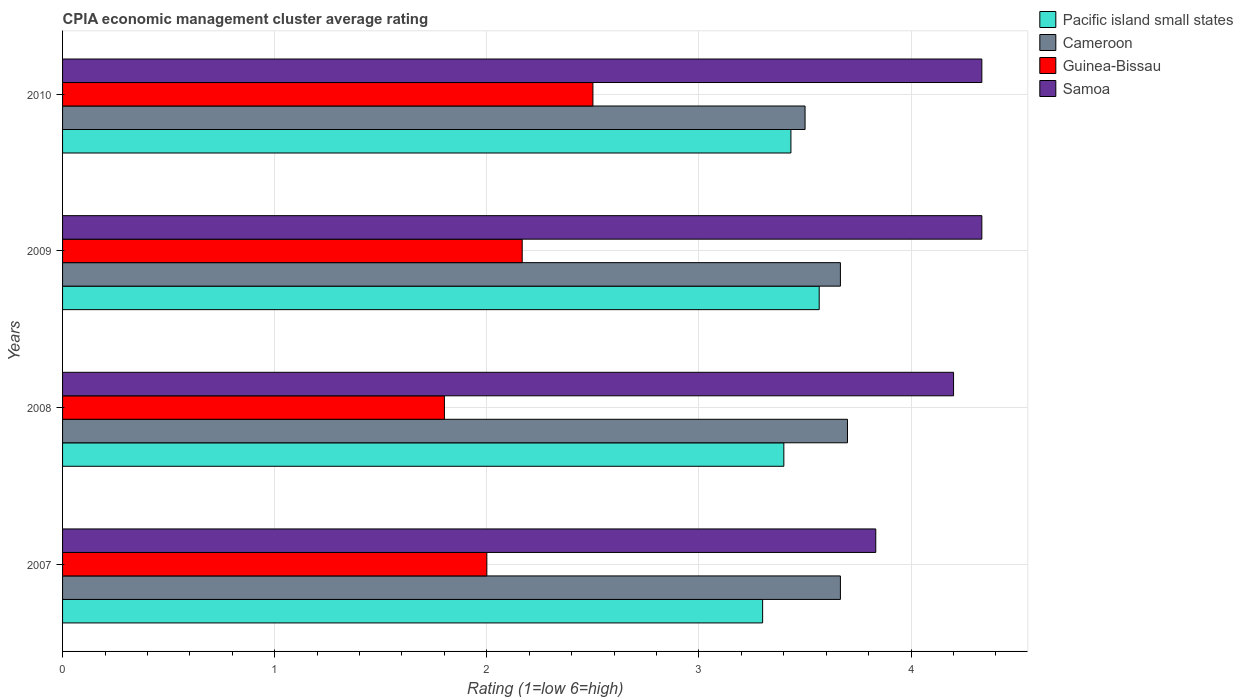How many different coloured bars are there?
Make the answer very short. 4. How many groups of bars are there?
Your answer should be very brief. 4. Are the number of bars per tick equal to the number of legend labels?
Make the answer very short. Yes. How many bars are there on the 1st tick from the top?
Your answer should be very brief. 4. What is the label of the 3rd group of bars from the top?
Your answer should be compact. 2008. In how many cases, is the number of bars for a given year not equal to the number of legend labels?
Your answer should be compact. 0. What is the CPIA rating in Pacific island small states in 2010?
Provide a short and direct response. 3.43. Across all years, what is the minimum CPIA rating in Cameroon?
Make the answer very short. 3.5. In which year was the CPIA rating in Pacific island small states maximum?
Ensure brevity in your answer.  2009. In which year was the CPIA rating in Cameroon minimum?
Provide a succinct answer. 2010. What is the total CPIA rating in Guinea-Bissau in the graph?
Your answer should be very brief. 8.47. What is the difference between the CPIA rating in Cameroon in 2007 and that in 2010?
Offer a very short reply. 0.17. What is the difference between the CPIA rating in Samoa in 2008 and the CPIA rating in Cameroon in 2007?
Offer a very short reply. 0.53. What is the average CPIA rating in Pacific island small states per year?
Provide a succinct answer. 3.42. In the year 2007, what is the difference between the CPIA rating in Samoa and CPIA rating in Pacific island small states?
Give a very brief answer. 0.53. What is the ratio of the CPIA rating in Guinea-Bissau in 2008 to that in 2009?
Your answer should be compact. 0.83. What is the difference between the highest and the second highest CPIA rating in Guinea-Bissau?
Offer a terse response. 0.33. What is the difference between the highest and the lowest CPIA rating in Cameroon?
Your answer should be compact. 0.2. In how many years, is the CPIA rating in Cameroon greater than the average CPIA rating in Cameroon taken over all years?
Offer a terse response. 3. Is it the case that in every year, the sum of the CPIA rating in Cameroon and CPIA rating in Pacific island small states is greater than the sum of CPIA rating in Guinea-Bissau and CPIA rating in Samoa?
Your answer should be very brief. Yes. What does the 4th bar from the top in 2008 represents?
Provide a succinct answer. Pacific island small states. What does the 3rd bar from the bottom in 2009 represents?
Your answer should be very brief. Guinea-Bissau. Are all the bars in the graph horizontal?
Offer a very short reply. Yes. Are the values on the major ticks of X-axis written in scientific E-notation?
Offer a very short reply. No. Does the graph contain grids?
Your answer should be compact. Yes. What is the title of the graph?
Keep it short and to the point. CPIA economic management cluster average rating. What is the Rating (1=low 6=high) in Pacific island small states in 2007?
Offer a terse response. 3.3. What is the Rating (1=low 6=high) of Cameroon in 2007?
Give a very brief answer. 3.67. What is the Rating (1=low 6=high) of Guinea-Bissau in 2007?
Ensure brevity in your answer.  2. What is the Rating (1=low 6=high) in Samoa in 2007?
Your answer should be very brief. 3.83. What is the Rating (1=low 6=high) in Guinea-Bissau in 2008?
Offer a very short reply. 1.8. What is the Rating (1=low 6=high) of Pacific island small states in 2009?
Keep it short and to the point. 3.57. What is the Rating (1=low 6=high) in Cameroon in 2009?
Offer a terse response. 3.67. What is the Rating (1=low 6=high) of Guinea-Bissau in 2009?
Your answer should be compact. 2.17. What is the Rating (1=low 6=high) of Samoa in 2009?
Make the answer very short. 4.33. What is the Rating (1=low 6=high) in Pacific island small states in 2010?
Your answer should be very brief. 3.43. What is the Rating (1=low 6=high) of Cameroon in 2010?
Your response must be concise. 3.5. What is the Rating (1=low 6=high) in Guinea-Bissau in 2010?
Make the answer very short. 2.5. What is the Rating (1=low 6=high) of Samoa in 2010?
Offer a very short reply. 4.33. Across all years, what is the maximum Rating (1=low 6=high) in Pacific island small states?
Give a very brief answer. 3.57. Across all years, what is the maximum Rating (1=low 6=high) in Samoa?
Provide a succinct answer. 4.33. Across all years, what is the minimum Rating (1=low 6=high) in Samoa?
Your answer should be very brief. 3.83. What is the total Rating (1=low 6=high) in Pacific island small states in the graph?
Provide a succinct answer. 13.7. What is the total Rating (1=low 6=high) of Cameroon in the graph?
Give a very brief answer. 14.53. What is the total Rating (1=low 6=high) in Guinea-Bissau in the graph?
Ensure brevity in your answer.  8.47. What is the total Rating (1=low 6=high) of Samoa in the graph?
Ensure brevity in your answer.  16.7. What is the difference between the Rating (1=low 6=high) of Cameroon in 2007 and that in 2008?
Provide a succinct answer. -0.03. What is the difference between the Rating (1=low 6=high) of Guinea-Bissau in 2007 and that in 2008?
Provide a short and direct response. 0.2. What is the difference between the Rating (1=low 6=high) of Samoa in 2007 and that in 2008?
Your response must be concise. -0.37. What is the difference between the Rating (1=low 6=high) of Pacific island small states in 2007 and that in 2009?
Make the answer very short. -0.27. What is the difference between the Rating (1=low 6=high) in Pacific island small states in 2007 and that in 2010?
Provide a succinct answer. -0.13. What is the difference between the Rating (1=low 6=high) in Guinea-Bissau in 2007 and that in 2010?
Your answer should be very brief. -0.5. What is the difference between the Rating (1=low 6=high) of Guinea-Bissau in 2008 and that in 2009?
Make the answer very short. -0.37. What is the difference between the Rating (1=low 6=high) of Samoa in 2008 and that in 2009?
Keep it short and to the point. -0.13. What is the difference between the Rating (1=low 6=high) in Pacific island small states in 2008 and that in 2010?
Offer a terse response. -0.03. What is the difference between the Rating (1=low 6=high) of Cameroon in 2008 and that in 2010?
Keep it short and to the point. 0.2. What is the difference between the Rating (1=low 6=high) in Samoa in 2008 and that in 2010?
Provide a short and direct response. -0.13. What is the difference between the Rating (1=low 6=high) of Pacific island small states in 2009 and that in 2010?
Your answer should be very brief. 0.13. What is the difference between the Rating (1=low 6=high) in Pacific island small states in 2007 and the Rating (1=low 6=high) in Samoa in 2008?
Offer a very short reply. -0.9. What is the difference between the Rating (1=low 6=high) in Cameroon in 2007 and the Rating (1=low 6=high) in Guinea-Bissau in 2008?
Make the answer very short. 1.87. What is the difference between the Rating (1=low 6=high) in Cameroon in 2007 and the Rating (1=low 6=high) in Samoa in 2008?
Provide a short and direct response. -0.53. What is the difference between the Rating (1=low 6=high) of Guinea-Bissau in 2007 and the Rating (1=low 6=high) of Samoa in 2008?
Provide a short and direct response. -2.2. What is the difference between the Rating (1=low 6=high) of Pacific island small states in 2007 and the Rating (1=low 6=high) of Cameroon in 2009?
Give a very brief answer. -0.37. What is the difference between the Rating (1=low 6=high) in Pacific island small states in 2007 and the Rating (1=low 6=high) in Guinea-Bissau in 2009?
Ensure brevity in your answer.  1.13. What is the difference between the Rating (1=low 6=high) of Pacific island small states in 2007 and the Rating (1=low 6=high) of Samoa in 2009?
Make the answer very short. -1.03. What is the difference between the Rating (1=low 6=high) of Cameroon in 2007 and the Rating (1=low 6=high) of Guinea-Bissau in 2009?
Offer a terse response. 1.5. What is the difference between the Rating (1=low 6=high) of Cameroon in 2007 and the Rating (1=low 6=high) of Samoa in 2009?
Your response must be concise. -0.67. What is the difference between the Rating (1=low 6=high) of Guinea-Bissau in 2007 and the Rating (1=low 6=high) of Samoa in 2009?
Make the answer very short. -2.33. What is the difference between the Rating (1=low 6=high) in Pacific island small states in 2007 and the Rating (1=low 6=high) in Samoa in 2010?
Provide a succinct answer. -1.03. What is the difference between the Rating (1=low 6=high) of Cameroon in 2007 and the Rating (1=low 6=high) of Guinea-Bissau in 2010?
Offer a terse response. 1.17. What is the difference between the Rating (1=low 6=high) in Cameroon in 2007 and the Rating (1=low 6=high) in Samoa in 2010?
Offer a terse response. -0.67. What is the difference between the Rating (1=low 6=high) in Guinea-Bissau in 2007 and the Rating (1=low 6=high) in Samoa in 2010?
Offer a terse response. -2.33. What is the difference between the Rating (1=low 6=high) of Pacific island small states in 2008 and the Rating (1=low 6=high) of Cameroon in 2009?
Provide a short and direct response. -0.27. What is the difference between the Rating (1=low 6=high) of Pacific island small states in 2008 and the Rating (1=low 6=high) of Guinea-Bissau in 2009?
Ensure brevity in your answer.  1.23. What is the difference between the Rating (1=low 6=high) of Pacific island small states in 2008 and the Rating (1=low 6=high) of Samoa in 2009?
Offer a very short reply. -0.93. What is the difference between the Rating (1=low 6=high) of Cameroon in 2008 and the Rating (1=low 6=high) of Guinea-Bissau in 2009?
Your answer should be very brief. 1.53. What is the difference between the Rating (1=low 6=high) in Cameroon in 2008 and the Rating (1=low 6=high) in Samoa in 2009?
Your answer should be very brief. -0.63. What is the difference between the Rating (1=low 6=high) of Guinea-Bissau in 2008 and the Rating (1=low 6=high) of Samoa in 2009?
Provide a short and direct response. -2.53. What is the difference between the Rating (1=low 6=high) in Pacific island small states in 2008 and the Rating (1=low 6=high) in Cameroon in 2010?
Offer a very short reply. -0.1. What is the difference between the Rating (1=low 6=high) of Pacific island small states in 2008 and the Rating (1=low 6=high) of Guinea-Bissau in 2010?
Make the answer very short. 0.9. What is the difference between the Rating (1=low 6=high) in Pacific island small states in 2008 and the Rating (1=low 6=high) in Samoa in 2010?
Your answer should be compact. -0.93. What is the difference between the Rating (1=low 6=high) of Cameroon in 2008 and the Rating (1=low 6=high) of Samoa in 2010?
Your answer should be compact. -0.63. What is the difference between the Rating (1=low 6=high) of Guinea-Bissau in 2008 and the Rating (1=low 6=high) of Samoa in 2010?
Offer a terse response. -2.53. What is the difference between the Rating (1=low 6=high) in Pacific island small states in 2009 and the Rating (1=low 6=high) in Cameroon in 2010?
Make the answer very short. 0.07. What is the difference between the Rating (1=low 6=high) in Pacific island small states in 2009 and the Rating (1=low 6=high) in Guinea-Bissau in 2010?
Provide a succinct answer. 1.07. What is the difference between the Rating (1=low 6=high) in Pacific island small states in 2009 and the Rating (1=low 6=high) in Samoa in 2010?
Provide a succinct answer. -0.77. What is the difference between the Rating (1=low 6=high) of Cameroon in 2009 and the Rating (1=low 6=high) of Guinea-Bissau in 2010?
Provide a short and direct response. 1.17. What is the difference between the Rating (1=low 6=high) of Cameroon in 2009 and the Rating (1=low 6=high) of Samoa in 2010?
Offer a very short reply. -0.67. What is the difference between the Rating (1=low 6=high) in Guinea-Bissau in 2009 and the Rating (1=low 6=high) in Samoa in 2010?
Your answer should be very brief. -2.17. What is the average Rating (1=low 6=high) in Pacific island small states per year?
Offer a very short reply. 3.42. What is the average Rating (1=low 6=high) in Cameroon per year?
Provide a short and direct response. 3.63. What is the average Rating (1=low 6=high) of Guinea-Bissau per year?
Offer a very short reply. 2.12. What is the average Rating (1=low 6=high) in Samoa per year?
Offer a terse response. 4.17. In the year 2007, what is the difference between the Rating (1=low 6=high) in Pacific island small states and Rating (1=low 6=high) in Cameroon?
Provide a succinct answer. -0.37. In the year 2007, what is the difference between the Rating (1=low 6=high) of Pacific island small states and Rating (1=low 6=high) of Guinea-Bissau?
Provide a short and direct response. 1.3. In the year 2007, what is the difference between the Rating (1=low 6=high) in Pacific island small states and Rating (1=low 6=high) in Samoa?
Ensure brevity in your answer.  -0.53. In the year 2007, what is the difference between the Rating (1=low 6=high) of Cameroon and Rating (1=low 6=high) of Samoa?
Keep it short and to the point. -0.17. In the year 2007, what is the difference between the Rating (1=low 6=high) in Guinea-Bissau and Rating (1=low 6=high) in Samoa?
Provide a short and direct response. -1.83. In the year 2008, what is the difference between the Rating (1=low 6=high) in Pacific island small states and Rating (1=low 6=high) in Cameroon?
Give a very brief answer. -0.3. In the year 2008, what is the difference between the Rating (1=low 6=high) of Cameroon and Rating (1=low 6=high) of Guinea-Bissau?
Your answer should be compact. 1.9. In the year 2008, what is the difference between the Rating (1=low 6=high) in Guinea-Bissau and Rating (1=low 6=high) in Samoa?
Provide a succinct answer. -2.4. In the year 2009, what is the difference between the Rating (1=low 6=high) in Pacific island small states and Rating (1=low 6=high) in Cameroon?
Your response must be concise. -0.1. In the year 2009, what is the difference between the Rating (1=low 6=high) in Pacific island small states and Rating (1=low 6=high) in Guinea-Bissau?
Keep it short and to the point. 1.4. In the year 2009, what is the difference between the Rating (1=low 6=high) in Pacific island small states and Rating (1=low 6=high) in Samoa?
Give a very brief answer. -0.77. In the year 2009, what is the difference between the Rating (1=low 6=high) of Guinea-Bissau and Rating (1=low 6=high) of Samoa?
Make the answer very short. -2.17. In the year 2010, what is the difference between the Rating (1=low 6=high) of Pacific island small states and Rating (1=low 6=high) of Cameroon?
Your answer should be compact. -0.07. In the year 2010, what is the difference between the Rating (1=low 6=high) in Pacific island small states and Rating (1=low 6=high) in Guinea-Bissau?
Your answer should be compact. 0.93. In the year 2010, what is the difference between the Rating (1=low 6=high) in Cameroon and Rating (1=low 6=high) in Guinea-Bissau?
Provide a succinct answer. 1. In the year 2010, what is the difference between the Rating (1=low 6=high) in Guinea-Bissau and Rating (1=low 6=high) in Samoa?
Offer a terse response. -1.83. What is the ratio of the Rating (1=low 6=high) of Pacific island small states in 2007 to that in 2008?
Give a very brief answer. 0.97. What is the ratio of the Rating (1=low 6=high) in Samoa in 2007 to that in 2008?
Give a very brief answer. 0.91. What is the ratio of the Rating (1=low 6=high) in Pacific island small states in 2007 to that in 2009?
Give a very brief answer. 0.93. What is the ratio of the Rating (1=low 6=high) in Samoa in 2007 to that in 2009?
Offer a very short reply. 0.88. What is the ratio of the Rating (1=low 6=high) in Pacific island small states in 2007 to that in 2010?
Offer a very short reply. 0.96. What is the ratio of the Rating (1=low 6=high) of Cameroon in 2007 to that in 2010?
Give a very brief answer. 1.05. What is the ratio of the Rating (1=low 6=high) in Guinea-Bissau in 2007 to that in 2010?
Provide a succinct answer. 0.8. What is the ratio of the Rating (1=low 6=high) of Samoa in 2007 to that in 2010?
Offer a terse response. 0.88. What is the ratio of the Rating (1=low 6=high) in Pacific island small states in 2008 to that in 2009?
Your answer should be compact. 0.95. What is the ratio of the Rating (1=low 6=high) in Cameroon in 2008 to that in 2009?
Offer a terse response. 1.01. What is the ratio of the Rating (1=low 6=high) of Guinea-Bissau in 2008 to that in 2009?
Give a very brief answer. 0.83. What is the ratio of the Rating (1=low 6=high) of Samoa in 2008 to that in 2009?
Offer a very short reply. 0.97. What is the ratio of the Rating (1=low 6=high) in Pacific island small states in 2008 to that in 2010?
Give a very brief answer. 0.99. What is the ratio of the Rating (1=low 6=high) of Cameroon in 2008 to that in 2010?
Provide a short and direct response. 1.06. What is the ratio of the Rating (1=low 6=high) of Guinea-Bissau in 2008 to that in 2010?
Give a very brief answer. 0.72. What is the ratio of the Rating (1=low 6=high) of Samoa in 2008 to that in 2010?
Keep it short and to the point. 0.97. What is the ratio of the Rating (1=low 6=high) of Pacific island small states in 2009 to that in 2010?
Your response must be concise. 1.04. What is the ratio of the Rating (1=low 6=high) of Cameroon in 2009 to that in 2010?
Your response must be concise. 1.05. What is the ratio of the Rating (1=low 6=high) of Guinea-Bissau in 2009 to that in 2010?
Offer a terse response. 0.87. What is the ratio of the Rating (1=low 6=high) of Samoa in 2009 to that in 2010?
Your answer should be compact. 1. What is the difference between the highest and the second highest Rating (1=low 6=high) in Pacific island small states?
Ensure brevity in your answer.  0.13. What is the difference between the highest and the second highest Rating (1=low 6=high) of Guinea-Bissau?
Make the answer very short. 0.33. What is the difference between the highest and the second highest Rating (1=low 6=high) in Samoa?
Make the answer very short. 0. What is the difference between the highest and the lowest Rating (1=low 6=high) in Pacific island small states?
Provide a succinct answer. 0.27. What is the difference between the highest and the lowest Rating (1=low 6=high) in Cameroon?
Your answer should be very brief. 0.2. 